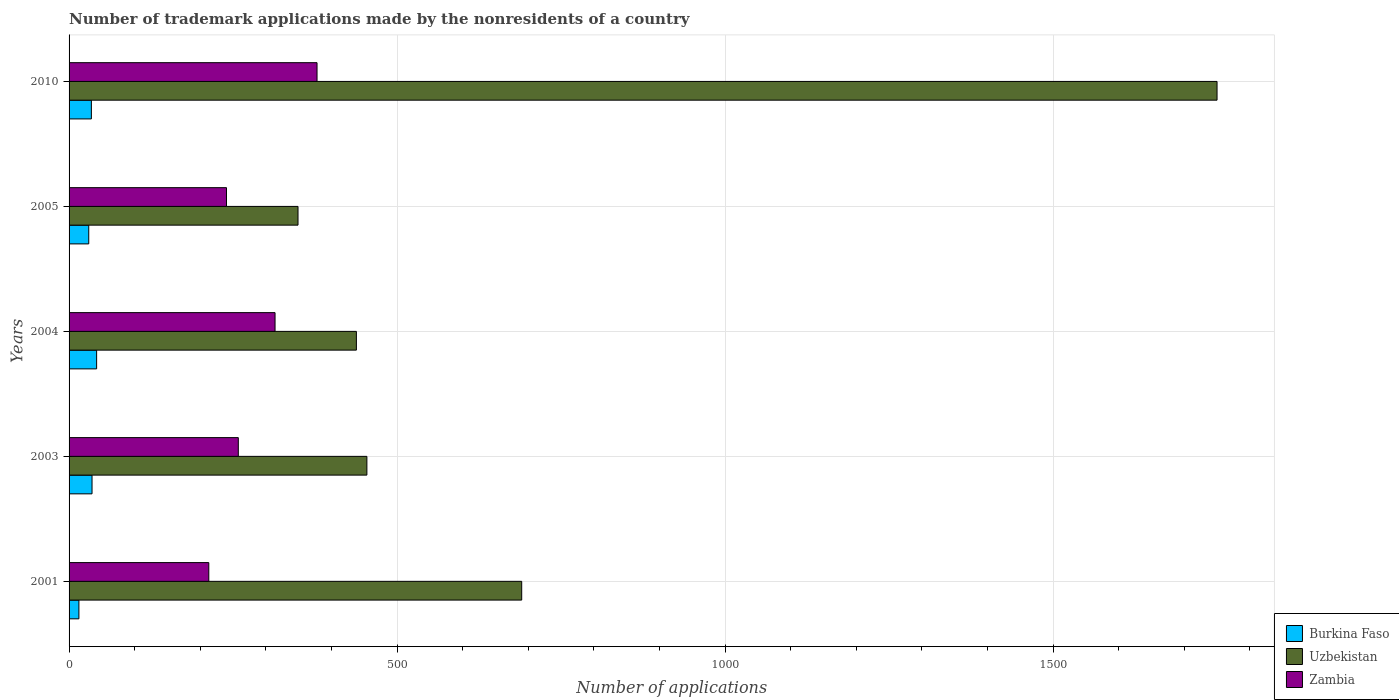Are the number of bars per tick equal to the number of legend labels?
Your response must be concise. Yes. How many bars are there on the 2nd tick from the top?
Ensure brevity in your answer.  3. In how many cases, is the number of bars for a given year not equal to the number of legend labels?
Ensure brevity in your answer.  0. What is the number of trademark applications made by the nonresidents in Burkina Faso in 2005?
Provide a short and direct response. 30. Across all years, what is the maximum number of trademark applications made by the nonresidents in Uzbekistan?
Your answer should be very brief. 1750. In which year was the number of trademark applications made by the nonresidents in Uzbekistan minimum?
Ensure brevity in your answer.  2005. What is the total number of trademark applications made by the nonresidents in Zambia in the graph?
Your answer should be very brief. 1403. What is the difference between the number of trademark applications made by the nonresidents in Uzbekistan in 2001 and that in 2010?
Ensure brevity in your answer.  -1060. What is the difference between the number of trademark applications made by the nonresidents in Zambia in 2005 and the number of trademark applications made by the nonresidents in Burkina Faso in 2003?
Give a very brief answer. 205. What is the average number of trademark applications made by the nonresidents in Burkina Faso per year?
Your answer should be compact. 31.2. In the year 2004, what is the difference between the number of trademark applications made by the nonresidents in Uzbekistan and number of trademark applications made by the nonresidents in Burkina Faso?
Provide a short and direct response. 396. What is the ratio of the number of trademark applications made by the nonresidents in Zambia in 2003 to that in 2004?
Your answer should be compact. 0.82. What is the difference between the highest and the second highest number of trademark applications made by the nonresidents in Uzbekistan?
Offer a terse response. 1060. What is the difference between the highest and the lowest number of trademark applications made by the nonresidents in Uzbekistan?
Give a very brief answer. 1401. In how many years, is the number of trademark applications made by the nonresidents in Uzbekistan greater than the average number of trademark applications made by the nonresidents in Uzbekistan taken over all years?
Your answer should be very brief. 1. Is the sum of the number of trademark applications made by the nonresidents in Burkina Faso in 2001 and 2003 greater than the maximum number of trademark applications made by the nonresidents in Zambia across all years?
Ensure brevity in your answer.  No. What does the 3rd bar from the top in 2001 represents?
Provide a succinct answer. Burkina Faso. What does the 3rd bar from the bottom in 2010 represents?
Give a very brief answer. Zambia. Is it the case that in every year, the sum of the number of trademark applications made by the nonresidents in Uzbekistan and number of trademark applications made by the nonresidents in Burkina Faso is greater than the number of trademark applications made by the nonresidents in Zambia?
Your answer should be very brief. Yes. How many bars are there?
Offer a terse response. 15. Are all the bars in the graph horizontal?
Provide a short and direct response. Yes. What is the difference between two consecutive major ticks on the X-axis?
Make the answer very short. 500. How are the legend labels stacked?
Provide a succinct answer. Vertical. What is the title of the graph?
Give a very brief answer. Number of trademark applications made by the nonresidents of a country. What is the label or title of the X-axis?
Offer a terse response. Number of applications. What is the label or title of the Y-axis?
Provide a succinct answer. Years. What is the Number of applications of Burkina Faso in 2001?
Provide a short and direct response. 15. What is the Number of applications of Uzbekistan in 2001?
Provide a succinct answer. 690. What is the Number of applications of Zambia in 2001?
Your answer should be compact. 213. What is the Number of applications in Burkina Faso in 2003?
Provide a short and direct response. 35. What is the Number of applications of Uzbekistan in 2003?
Offer a terse response. 454. What is the Number of applications of Zambia in 2003?
Offer a terse response. 258. What is the Number of applications in Burkina Faso in 2004?
Make the answer very short. 42. What is the Number of applications of Uzbekistan in 2004?
Keep it short and to the point. 438. What is the Number of applications in Zambia in 2004?
Offer a very short reply. 314. What is the Number of applications of Uzbekistan in 2005?
Your response must be concise. 349. What is the Number of applications of Zambia in 2005?
Ensure brevity in your answer.  240. What is the Number of applications of Burkina Faso in 2010?
Keep it short and to the point. 34. What is the Number of applications in Uzbekistan in 2010?
Offer a very short reply. 1750. What is the Number of applications in Zambia in 2010?
Your answer should be very brief. 378. Across all years, what is the maximum Number of applications of Uzbekistan?
Keep it short and to the point. 1750. Across all years, what is the maximum Number of applications in Zambia?
Give a very brief answer. 378. Across all years, what is the minimum Number of applications in Uzbekistan?
Offer a terse response. 349. Across all years, what is the minimum Number of applications of Zambia?
Keep it short and to the point. 213. What is the total Number of applications of Burkina Faso in the graph?
Ensure brevity in your answer.  156. What is the total Number of applications in Uzbekistan in the graph?
Ensure brevity in your answer.  3681. What is the total Number of applications of Zambia in the graph?
Offer a terse response. 1403. What is the difference between the Number of applications in Uzbekistan in 2001 and that in 2003?
Provide a short and direct response. 236. What is the difference between the Number of applications of Zambia in 2001 and that in 2003?
Give a very brief answer. -45. What is the difference between the Number of applications of Burkina Faso in 2001 and that in 2004?
Provide a short and direct response. -27. What is the difference between the Number of applications in Uzbekistan in 2001 and that in 2004?
Keep it short and to the point. 252. What is the difference between the Number of applications of Zambia in 2001 and that in 2004?
Provide a succinct answer. -101. What is the difference between the Number of applications of Uzbekistan in 2001 and that in 2005?
Provide a succinct answer. 341. What is the difference between the Number of applications of Uzbekistan in 2001 and that in 2010?
Your response must be concise. -1060. What is the difference between the Number of applications in Zambia in 2001 and that in 2010?
Your answer should be compact. -165. What is the difference between the Number of applications of Burkina Faso in 2003 and that in 2004?
Ensure brevity in your answer.  -7. What is the difference between the Number of applications in Zambia in 2003 and that in 2004?
Make the answer very short. -56. What is the difference between the Number of applications in Uzbekistan in 2003 and that in 2005?
Offer a very short reply. 105. What is the difference between the Number of applications in Zambia in 2003 and that in 2005?
Offer a very short reply. 18. What is the difference between the Number of applications of Uzbekistan in 2003 and that in 2010?
Offer a very short reply. -1296. What is the difference between the Number of applications of Zambia in 2003 and that in 2010?
Keep it short and to the point. -120. What is the difference between the Number of applications of Burkina Faso in 2004 and that in 2005?
Your answer should be very brief. 12. What is the difference between the Number of applications in Uzbekistan in 2004 and that in 2005?
Your answer should be compact. 89. What is the difference between the Number of applications of Uzbekistan in 2004 and that in 2010?
Make the answer very short. -1312. What is the difference between the Number of applications in Zambia in 2004 and that in 2010?
Your answer should be very brief. -64. What is the difference between the Number of applications of Uzbekistan in 2005 and that in 2010?
Provide a short and direct response. -1401. What is the difference between the Number of applications of Zambia in 2005 and that in 2010?
Give a very brief answer. -138. What is the difference between the Number of applications in Burkina Faso in 2001 and the Number of applications in Uzbekistan in 2003?
Keep it short and to the point. -439. What is the difference between the Number of applications in Burkina Faso in 2001 and the Number of applications in Zambia in 2003?
Your answer should be very brief. -243. What is the difference between the Number of applications in Uzbekistan in 2001 and the Number of applications in Zambia in 2003?
Make the answer very short. 432. What is the difference between the Number of applications in Burkina Faso in 2001 and the Number of applications in Uzbekistan in 2004?
Your answer should be compact. -423. What is the difference between the Number of applications in Burkina Faso in 2001 and the Number of applications in Zambia in 2004?
Ensure brevity in your answer.  -299. What is the difference between the Number of applications of Uzbekistan in 2001 and the Number of applications of Zambia in 2004?
Offer a very short reply. 376. What is the difference between the Number of applications in Burkina Faso in 2001 and the Number of applications in Uzbekistan in 2005?
Your answer should be compact. -334. What is the difference between the Number of applications in Burkina Faso in 2001 and the Number of applications in Zambia in 2005?
Offer a terse response. -225. What is the difference between the Number of applications in Uzbekistan in 2001 and the Number of applications in Zambia in 2005?
Make the answer very short. 450. What is the difference between the Number of applications of Burkina Faso in 2001 and the Number of applications of Uzbekistan in 2010?
Keep it short and to the point. -1735. What is the difference between the Number of applications of Burkina Faso in 2001 and the Number of applications of Zambia in 2010?
Ensure brevity in your answer.  -363. What is the difference between the Number of applications in Uzbekistan in 2001 and the Number of applications in Zambia in 2010?
Give a very brief answer. 312. What is the difference between the Number of applications of Burkina Faso in 2003 and the Number of applications of Uzbekistan in 2004?
Your response must be concise. -403. What is the difference between the Number of applications in Burkina Faso in 2003 and the Number of applications in Zambia in 2004?
Offer a terse response. -279. What is the difference between the Number of applications in Uzbekistan in 2003 and the Number of applications in Zambia in 2004?
Your answer should be compact. 140. What is the difference between the Number of applications in Burkina Faso in 2003 and the Number of applications in Uzbekistan in 2005?
Your response must be concise. -314. What is the difference between the Number of applications of Burkina Faso in 2003 and the Number of applications of Zambia in 2005?
Offer a terse response. -205. What is the difference between the Number of applications in Uzbekistan in 2003 and the Number of applications in Zambia in 2005?
Provide a short and direct response. 214. What is the difference between the Number of applications in Burkina Faso in 2003 and the Number of applications in Uzbekistan in 2010?
Offer a terse response. -1715. What is the difference between the Number of applications of Burkina Faso in 2003 and the Number of applications of Zambia in 2010?
Your answer should be compact. -343. What is the difference between the Number of applications of Burkina Faso in 2004 and the Number of applications of Uzbekistan in 2005?
Keep it short and to the point. -307. What is the difference between the Number of applications in Burkina Faso in 2004 and the Number of applications in Zambia in 2005?
Offer a very short reply. -198. What is the difference between the Number of applications in Uzbekistan in 2004 and the Number of applications in Zambia in 2005?
Your response must be concise. 198. What is the difference between the Number of applications in Burkina Faso in 2004 and the Number of applications in Uzbekistan in 2010?
Provide a short and direct response. -1708. What is the difference between the Number of applications of Burkina Faso in 2004 and the Number of applications of Zambia in 2010?
Ensure brevity in your answer.  -336. What is the difference between the Number of applications of Uzbekistan in 2004 and the Number of applications of Zambia in 2010?
Your answer should be very brief. 60. What is the difference between the Number of applications of Burkina Faso in 2005 and the Number of applications of Uzbekistan in 2010?
Ensure brevity in your answer.  -1720. What is the difference between the Number of applications in Burkina Faso in 2005 and the Number of applications in Zambia in 2010?
Your answer should be compact. -348. What is the difference between the Number of applications of Uzbekistan in 2005 and the Number of applications of Zambia in 2010?
Provide a short and direct response. -29. What is the average Number of applications of Burkina Faso per year?
Keep it short and to the point. 31.2. What is the average Number of applications in Uzbekistan per year?
Keep it short and to the point. 736.2. What is the average Number of applications of Zambia per year?
Your answer should be compact. 280.6. In the year 2001, what is the difference between the Number of applications of Burkina Faso and Number of applications of Uzbekistan?
Your answer should be compact. -675. In the year 2001, what is the difference between the Number of applications of Burkina Faso and Number of applications of Zambia?
Your answer should be compact. -198. In the year 2001, what is the difference between the Number of applications of Uzbekistan and Number of applications of Zambia?
Provide a succinct answer. 477. In the year 2003, what is the difference between the Number of applications in Burkina Faso and Number of applications in Uzbekistan?
Your answer should be compact. -419. In the year 2003, what is the difference between the Number of applications in Burkina Faso and Number of applications in Zambia?
Offer a terse response. -223. In the year 2003, what is the difference between the Number of applications of Uzbekistan and Number of applications of Zambia?
Provide a short and direct response. 196. In the year 2004, what is the difference between the Number of applications of Burkina Faso and Number of applications of Uzbekistan?
Your answer should be very brief. -396. In the year 2004, what is the difference between the Number of applications of Burkina Faso and Number of applications of Zambia?
Give a very brief answer. -272. In the year 2004, what is the difference between the Number of applications in Uzbekistan and Number of applications in Zambia?
Offer a terse response. 124. In the year 2005, what is the difference between the Number of applications in Burkina Faso and Number of applications in Uzbekistan?
Make the answer very short. -319. In the year 2005, what is the difference between the Number of applications in Burkina Faso and Number of applications in Zambia?
Offer a very short reply. -210. In the year 2005, what is the difference between the Number of applications in Uzbekistan and Number of applications in Zambia?
Provide a succinct answer. 109. In the year 2010, what is the difference between the Number of applications of Burkina Faso and Number of applications of Uzbekistan?
Offer a terse response. -1716. In the year 2010, what is the difference between the Number of applications in Burkina Faso and Number of applications in Zambia?
Keep it short and to the point. -344. In the year 2010, what is the difference between the Number of applications of Uzbekistan and Number of applications of Zambia?
Keep it short and to the point. 1372. What is the ratio of the Number of applications of Burkina Faso in 2001 to that in 2003?
Ensure brevity in your answer.  0.43. What is the ratio of the Number of applications of Uzbekistan in 2001 to that in 2003?
Provide a short and direct response. 1.52. What is the ratio of the Number of applications of Zambia in 2001 to that in 2003?
Provide a short and direct response. 0.83. What is the ratio of the Number of applications in Burkina Faso in 2001 to that in 2004?
Your answer should be very brief. 0.36. What is the ratio of the Number of applications in Uzbekistan in 2001 to that in 2004?
Provide a short and direct response. 1.58. What is the ratio of the Number of applications of Zambia in 2001 to that in 2004?
Your response must be concise. 0.68. What is the ratio of the Number of applications of Burkina Faso in 2001 to that in 2005?
Make the answer very short. 0.5. What is the ratio of the Number of applications of Uzbekistan in 2001 to that in 2005?
Make the answer very short. 1.98. What is the ratio of the Number of applications of Zambia in 2001 to that in 2005?
Keep it short and to the point. 0.89. What is the ratio of the Number of applications of Burkina Faso in 2001 to that in 2010?
Give a very brief answer. 0.44. What is the ratio of the Number of applications in Uzbekistan in 2001 to that in 2010?
Provide a succinct answer. 0.39. What is the ratio of the Number of applications of Zambia in 2001 to that in 2010?
Make the answer very short. 0.56. What is the ratio of the Number of applications of Burkina Faso in 2003 to that in 2004?
Provide a succinct answer. 0.83. What is the ratio of the Number of applications of Uzbekistan in 2003 to that in 2004?
Offer a very short reply. 1.04. What is the ratio of the Number of applications of Zambia in 2003 to that in 2004?
Provide a short and direct response. 0.82. What is the ratio of the Number of applications of Uzbekistan in 2003 to that in 2005?
Offer a very short reply. 1.3. What is the ratio of the Number of applications in Zambia in 2003 to that in 2005?
Give a very brief answer. 1.07. What is the ratio of the Number of applications in Burkina Faso in 2003 to that in 2010?
Your answer should be compact. 1.03. What is the ratio of the Number of applications of Uzbekistan in 2003 to that in 2010?
Provide a succinct answer. 0.26. What is the ratio of the Number of applications of Zambia in 2003 to that in 2010?
Provide a succinct answer. 0.68. What is the ratio of the Number of applications of Uzbekistan in 2004 to that in 2005?
Give a very brief answer. 1.25. What is the ratio of the Number of applications of Zambia in 2004 to that in 2005?
Your answer should be very brief. 1.31. What is the ratio of the Number of applications of Burkina Faso in 2004 to that in 2010?
Keep it short and to the point. 1.24. What is the ratio of the Number of applications in Uzbekistan in 2004 to that in 2010?
Offer a terse response. 0.25. What is the ratio of the Number of applications of Zambia in 2004 to that in 2010?
Keep it short and to the point. 0.83. What is the ratio of the Number of applications of Burkina Faso in 2005 to that in 2010?
Provide a succinct answer. 0.88. What is the ratio of the Number of applications in Uzbekistan in 2005 to that in 2010?
Your answer should be compact. 0.2. What is the ratio of the Number of applications in Zambia in 2005 to that in 2010?
Offer a terse response. 0.63. What is the difference between the highest and the second highest Number of applications of Burkina Faso?
Offer a very short reply. 7. What is the difference between the highest and the second highest Number of applications in Uzbekistan?
Your answer should be very brief. 1060. What is the difference between the highest and the second highest Number of applications of Zambia?
Your answer should be compact. 64. What is the difference between the highest and the lowest Number of applications of Burkina Faso?
Make the answer very short. 27. What is the difference between the highest and the lowest Number of applications of Uzbekistan?
Ensure brevity in your answer.  1401. What is the difference between the highest and the lowest Number of applications in Zambia?
Offer a very short reply. 165. 